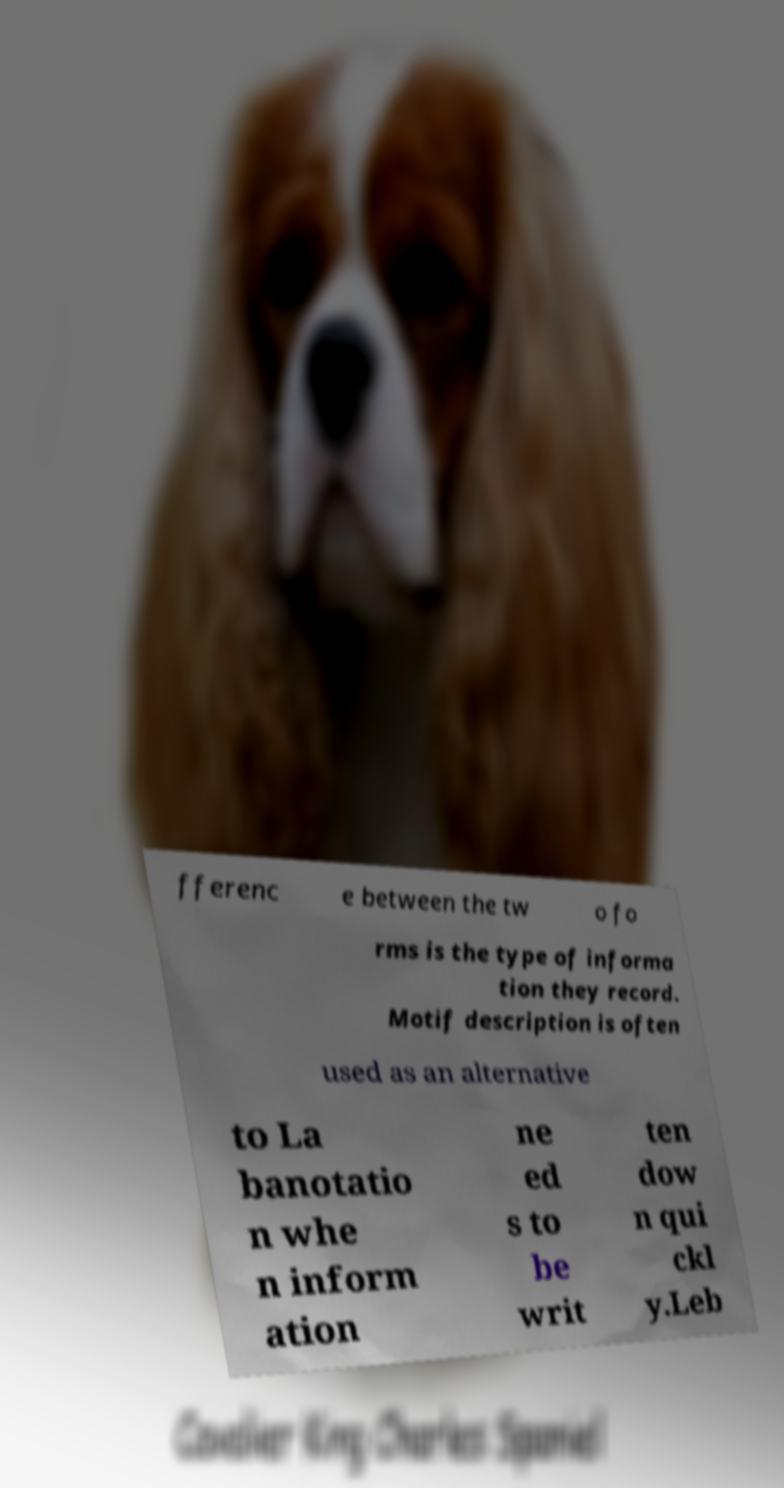What messages or text are displayed in this image? I need them in a readable, typed format. fferenc e between the tw o fo rms is the type of informa tion they record. Motif description is often used as an alternative to La banotatio n whe n inform ation ne ed s to be writ ten dow n qui ckl y.Leb 